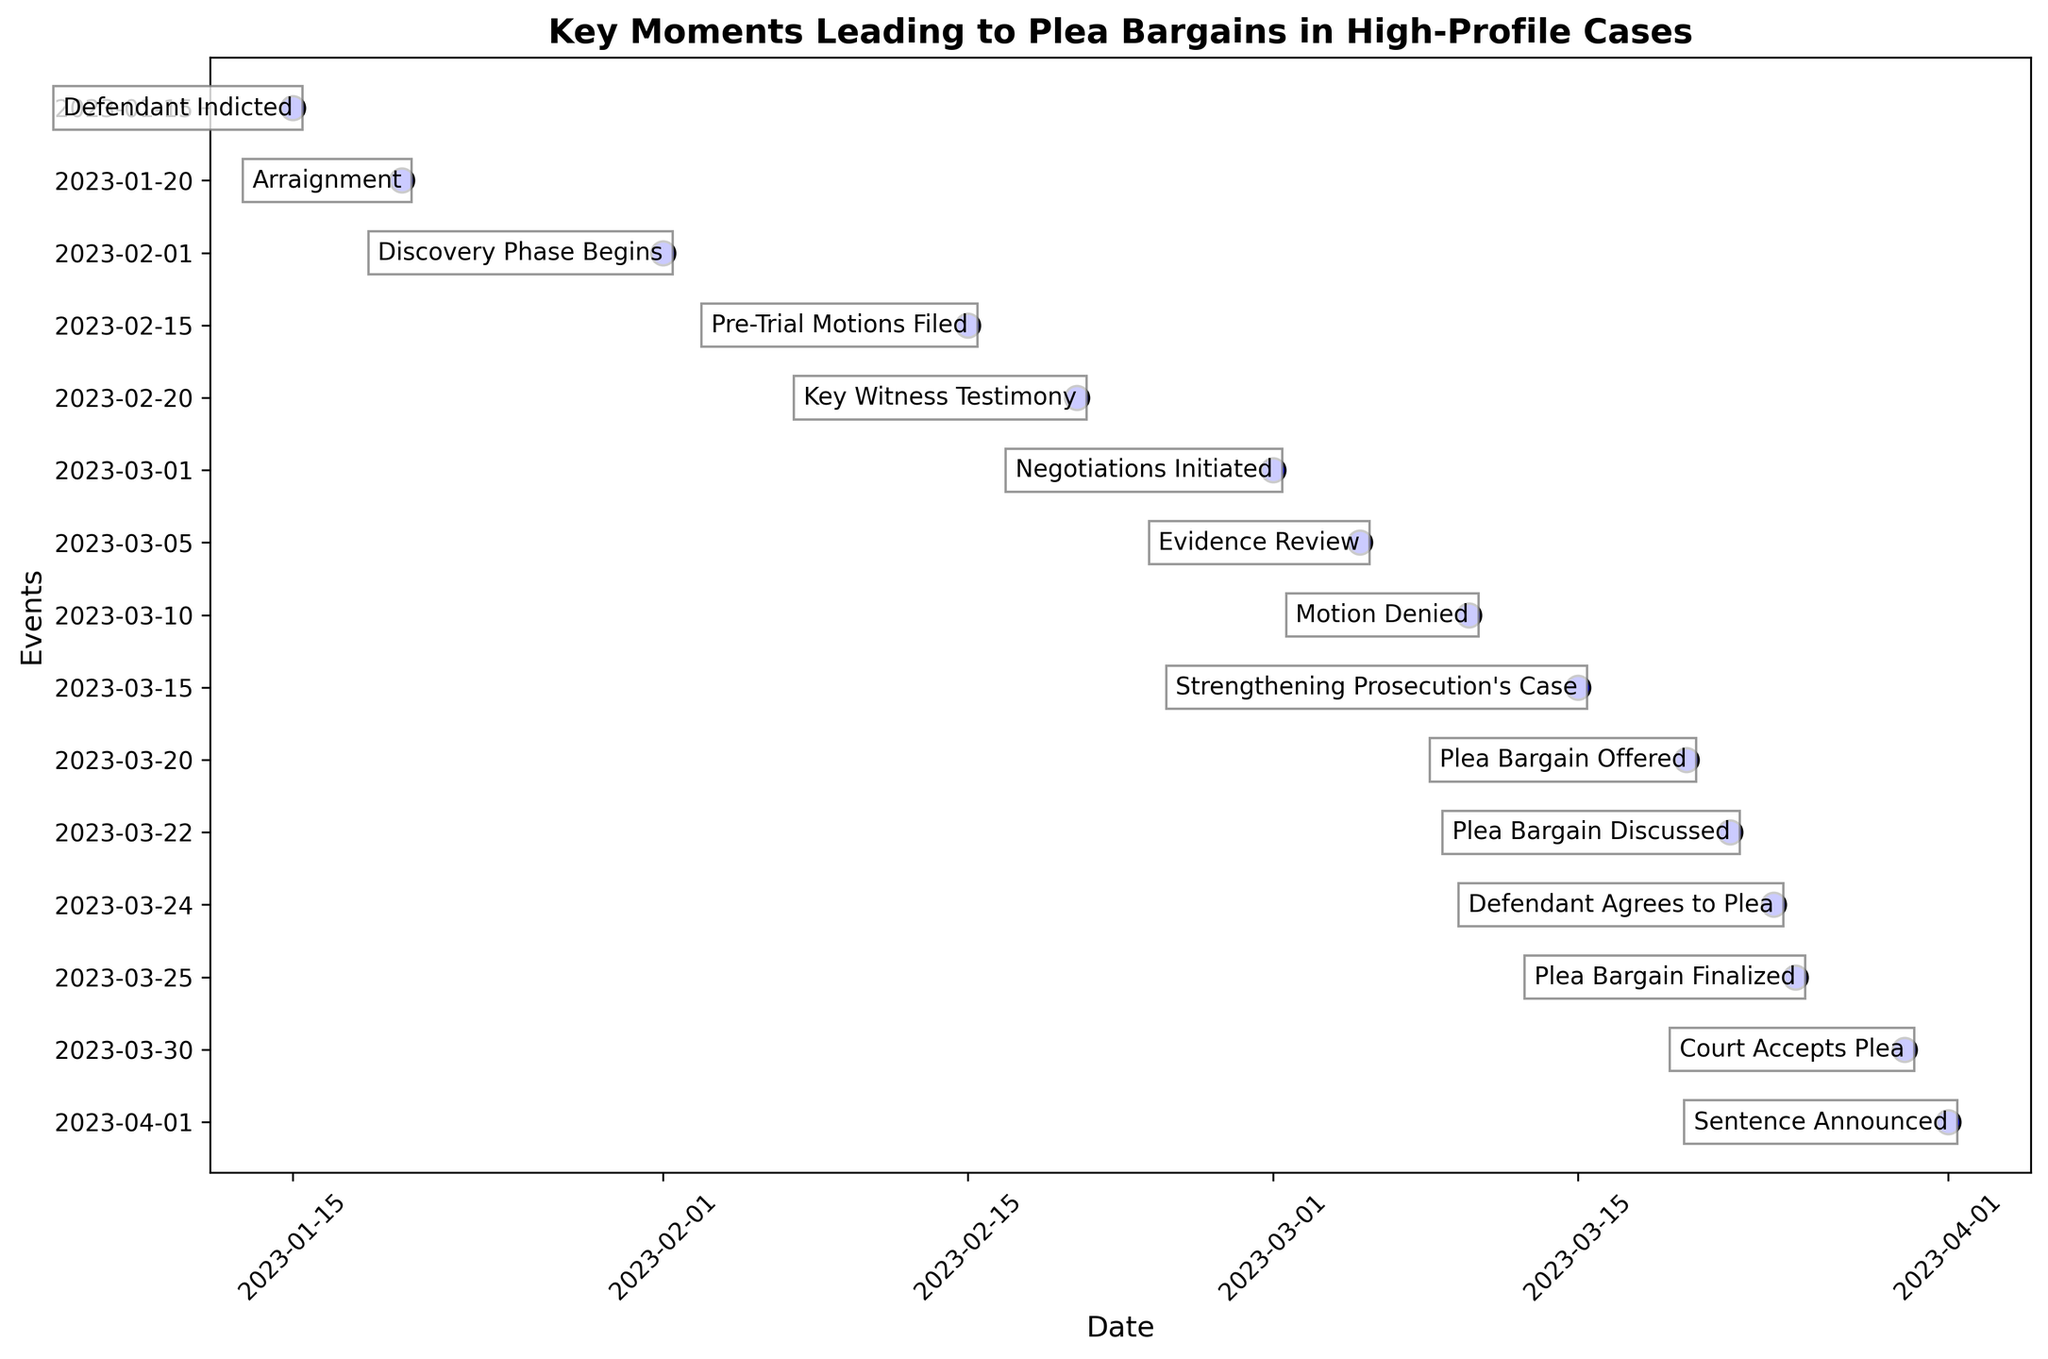What event occurred on 2023-02-20? First, identify the date 2023-02-20 on the y-axis. Then read the corresponding event annotation, which is "Key Witness Testimony."
Answer: Key Witness Testimony Which event happened first: 'Negotiations Initiated' or 'Strengthening Prosecution's Case'? Locate both events on the y-axis. 'Negotiations Initiated' occurred on 2023-03-01 and 'Strengthening Prosecution's Case' on 2023-03-15. 'Negotiations Initiated' happened first.
Answer: Negotiations Initiated What is the time difference between 'Defendant Indicted' and 'Discovery Phase Begins'? Identify the dates for both events. 'Defendant Indicted' is on 2023-01-15 and 'Discovery Phase Begins' is on 2023-02-01. Calculate the difference: 17 days in January + 1 day in February = 17 + 1 = 17 days.
Answer: 17 days How many events occurred in March 2023? Examine the dates in March 2023. The events are: 'Negotiations Initiated' (2023-03-01), 'Evidence Review' (2023-03-05), 'Motion Denied' (2023-03-10), 'Strengthening Prosecution's Case' (2023-03-15), 'Plea Bargain Offered' (2023-03-20), 'Plea Bargain Discussed' (2023-03-22), 'Defendant Agrees to Plea' (2023-03-24), 'Plea Bargain Finalized' (2023-03-25), and 'Court Accepts Plea' (2023-03-30). Count the number of events.
Answer: 9 Which event's description indicates the turning point for initiating plea discussions? Assess the descriptions for each event. 'Negotiations Initiated' states, "The defense initiated tentative discussions with the prosecution," indicating the turning point.
Answer: Negotiations Initiated When did the defendant agree to the plea bargain relative to when it was offered? Find the dates for 'Plea Bargain Offered' and 'Defendant Agrees to Plea'. 'Plea Bargain Offered' is on 2023-03-20, and 'Defendant Agrees to Plea' is on 2023-03-24. Calculate the difference: 24 - 20 = 4 days.
Answer: 4 days Which two events are marked closest together on the timeline? Identify the closest dates on the y-axis. 'Plea Bargain Discussed' (2023-03-22) and 'Defendant Agrees to Plea' (2023-03-24) are marked closest, with a gap of 2 days.
Answer: Plea Bargain Discussed and Defendant Agrees to Plea How many events occurred between 'Arraignment' and 'Strengthening Prosecution's Case'? Identify the events between 'Arraignment' (2023-01-20) and 'Strengthening Prosecution's Case' (2023-03-15). These include: 'Discovery Phase Begins', 'Pre-Trial Motions Filed', 'Key Witness Testimony', 'Negotiations Initiated', 'Evidence Review', and 'Motion Denied'. Count these events.
Answer: 6 Describe the sequence of events leading to the finalization of the plea bargain. Look at each event chronologically prior to 'Plea Bargain Finalized' (2023-03-25). The sequence includes: 'Defendant Indicted', 'Arraignment', 'Discovery Phase Begins', 'Pre-Trial Motions Filed', 'Key Witness Testimony', 'Negotiations Initiated', 'Evidence Review', 'Motion Denied', 'Strengthening Prosecution's Case', 'Plea Bargain Offered', 'Plea Bargain Discussed', and 'Defendant Agrees to Plea'.
Answer: Defendant Indicted, Arraignment, Discovery Phase Begins, Pre-Trial Motions Filed, Key Witness Testimony, Negotiations Initiated, Evidence Review, Motion Denied, Strengthening Prosecution's Case, Plea Bargain Offered, Plea Bargain Discussed, Defendant Agrees to Plea 